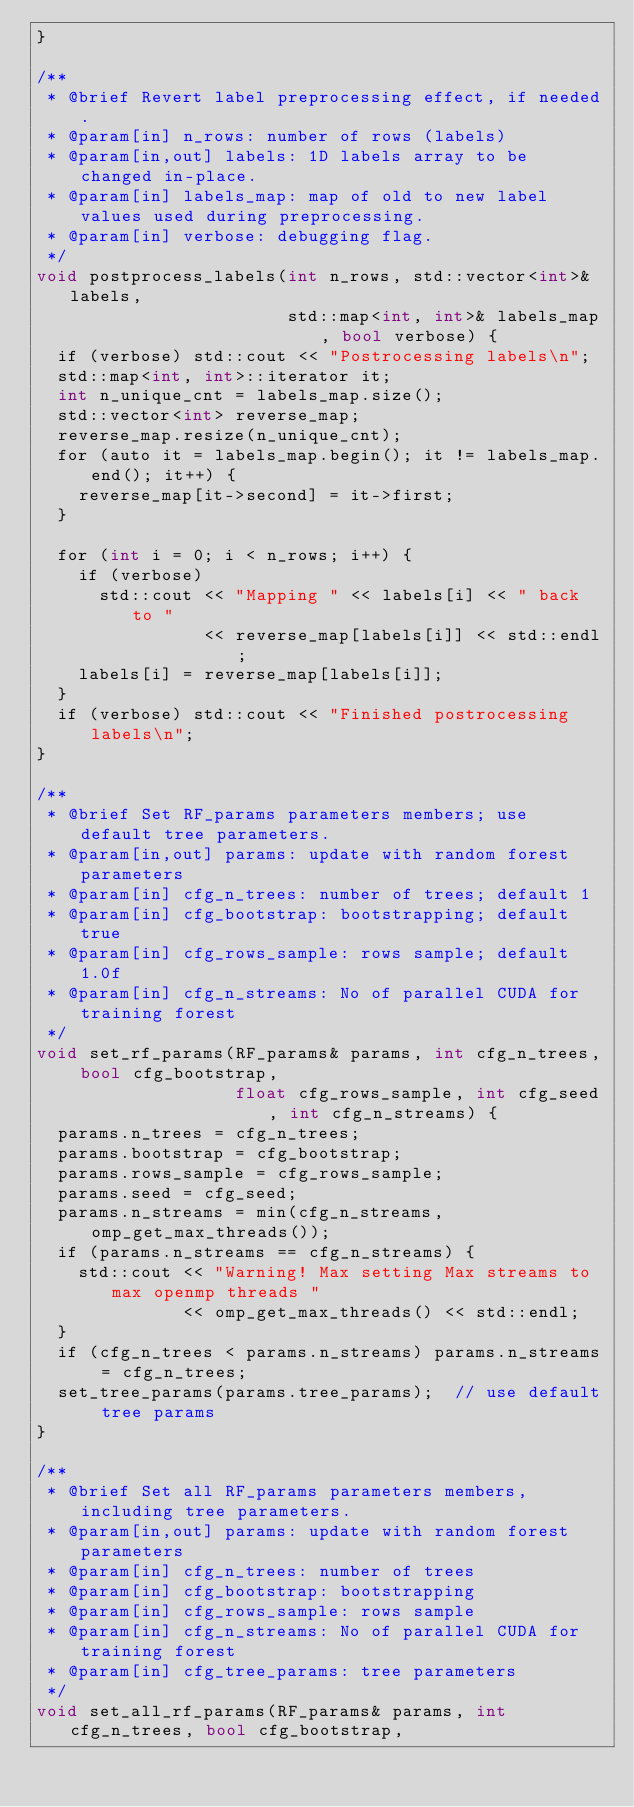Convert code to text. <code><loc_0><loc_0><loc_500><loc_500><_Cuda_>}

/**
 * @brief Revert label preprocessing effect, if needed.
 * @param[in] n_rows: number of rows (labels)
 * @param[in,out] labels: 1D labels array to be changed in-place.
 * @param[in] labels_map: map of old to new label values used during preprocessing.
 * @param[in] verbose: debugging flag.
 */
void postprocess_labels(int n_rows, std::vector<int>& labels,
                        std::map<int, int>& labels_map, bool verbose) {
  if (verbose) std::cout << "Postrocessing labels\n";
  std::map<int, int>::iterator it;
  int n_unique_cnt = labels_map.size();
  std::vector<int> reverse_map;
  reverse_map.resize(n_unique_cnt);
  for (auto it = labels_map.begin(); it != labels_map.end(); it++) {
    reverse_map[it->second] = it->first;
  }

  for (int i = 0; i < n_rows; i++) {
    if (verbose)
      std::cout << "Mapping " << labels[i] << " back to "
                << reverse_map[labels[i]] << std::endl;
    labels[i] = reverse_map[labels[i]];
  }
  if (verbose) std::cout << "Finished postrocessing labels\n";
}

/**
 * @brief Set RF_params parameters members; use default tree parameters.
 * @param[in,out] params: update with random forest parameters
 * @param[in] cfg_n_trees: number of trees; default 1
 * @param[in] cfg_bootstrap: bootstrapping; default true
 * @param[in] cfg_rows_sample: rows sample; default 1.0f
 * @param[in] cfg_n_streams: No of parallel CUDA for training forest
 */
void set_rf_params(RF_params& params, int cfg_n_trees, bool cfg_bootstrap,
                   float cfg_rows_sample, int cfg_seed, int cfg_n_streams) {
  params.n_trees = cfg_n_trees;
  params.bootstrap = cfg_bootstrap;
  params.rows_sample = cfg_rows_sample;
  params.seed = cfg_seed;
  params.n_streams = min(cfg_n_streams, omp_get_max_threads());
  if (params.n_streams == cfg_n_streams) {
    std::cout << "Warning! Max setting Max streams to max openmp threads "
              << omp_get_max_threads() << std::endl;
  }
  if (cfg_n_trees < params.n_streams) params.n_streams = cfg_n_trees;
  set_tree_params(params.tree_params);  // use default tree params
}

/**
 * @brief Set all RF_params parameters members, including tree parameters.
 * @param[in,out] params: update with random forest parameters
 * @param[in] cfg_n_trees: number of trees
 * @param[in] cfg_bootstrap: bootstrapping
 * @param[in] cfg_rows_sample: rows sample
 * @param[in] cfg_n_streams: No of parallel CUDA for training forest
 * @param[in] cfg_tree_params: tree parameters
 */
void set_all_rf_params(RF_params& params, int cfg_n_trees, bool cfg_bootstrap,</code> 